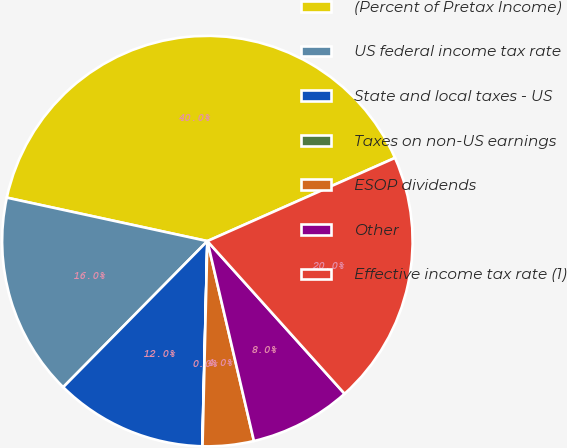<chart> <loc_0><loc_0><loc_500><loc_500><pie_chart><fcel>(Percent of Pretax Income)<fcel>US federal income tax rate<fcel>State and local taxes - US<fcel>Taxes on non-US earnings<fcel>ESOP dividends<fcel>Other<fcel>Effective income tax rate (1)<nl><fcel>39.96%<fcel>16.0%<fcel>12.0%<fcel>0.02%<fcel>4.02%<fcel>8.01%<fcel>19.99%<nl></chart> 